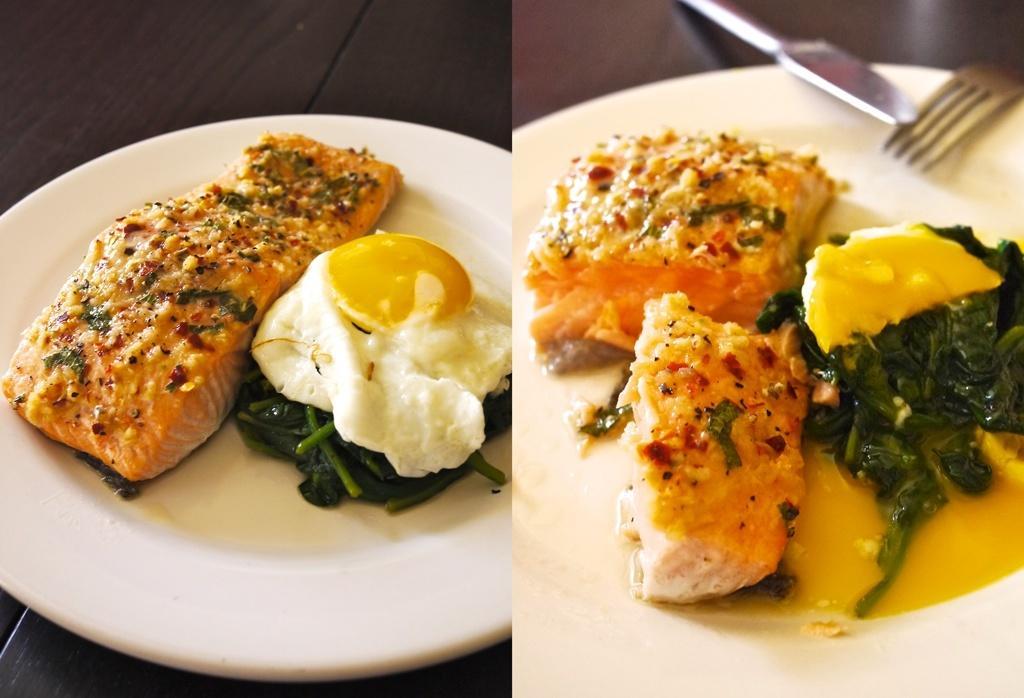Describe this image in one or two sentences. This is a collage image of food items with a fork and knife in plates on a table. 